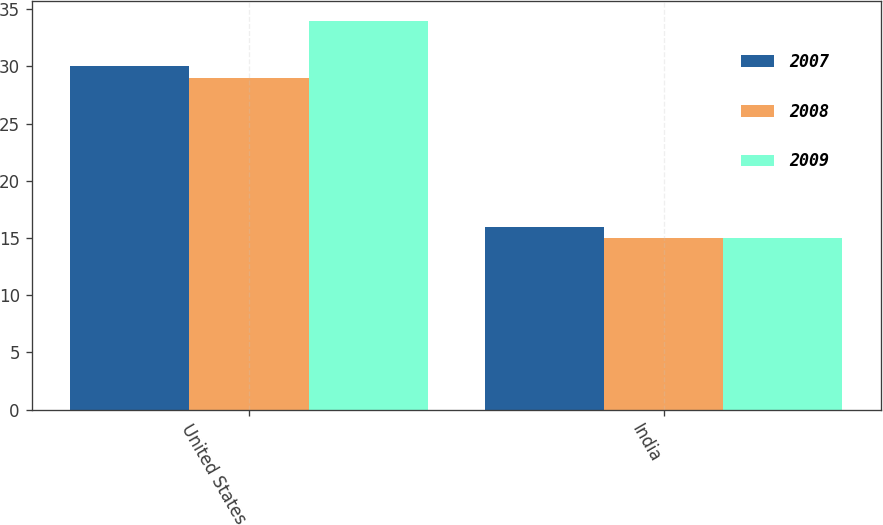Convert chart to OTSL. <chart><loc_0><loc_0><loc_500><loc_500><stacked_bar_chart><ecel><fcel>United States<fcel>India<nl><fcel>2007<fcel>30<fcel>16<nl><fcel>2008<fcel>29<fcel>15<nl><fcel>2009<fcel>34<fcel>15<nl></chart> 